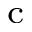<formula> <loc_0><loc_0><loc_500><loc_500>^ { c }</formula> 